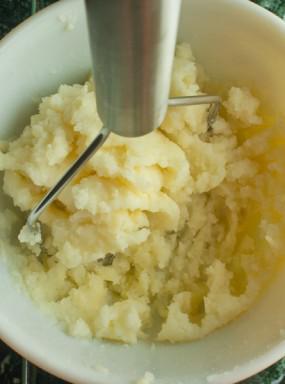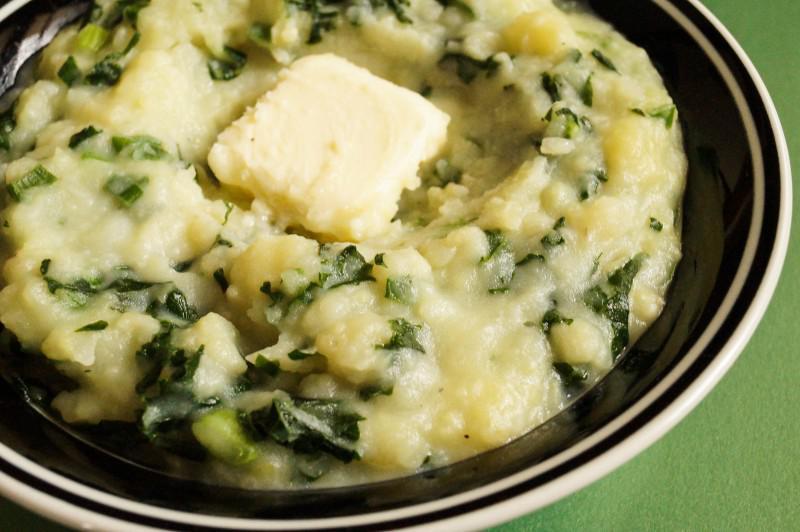The first image is the image on the left, the second image is the image on the right. For the images shown, is this caption "One serving of mashed potatoes is garnished with a pat of butter." true? Answer yes or no. Yes. 